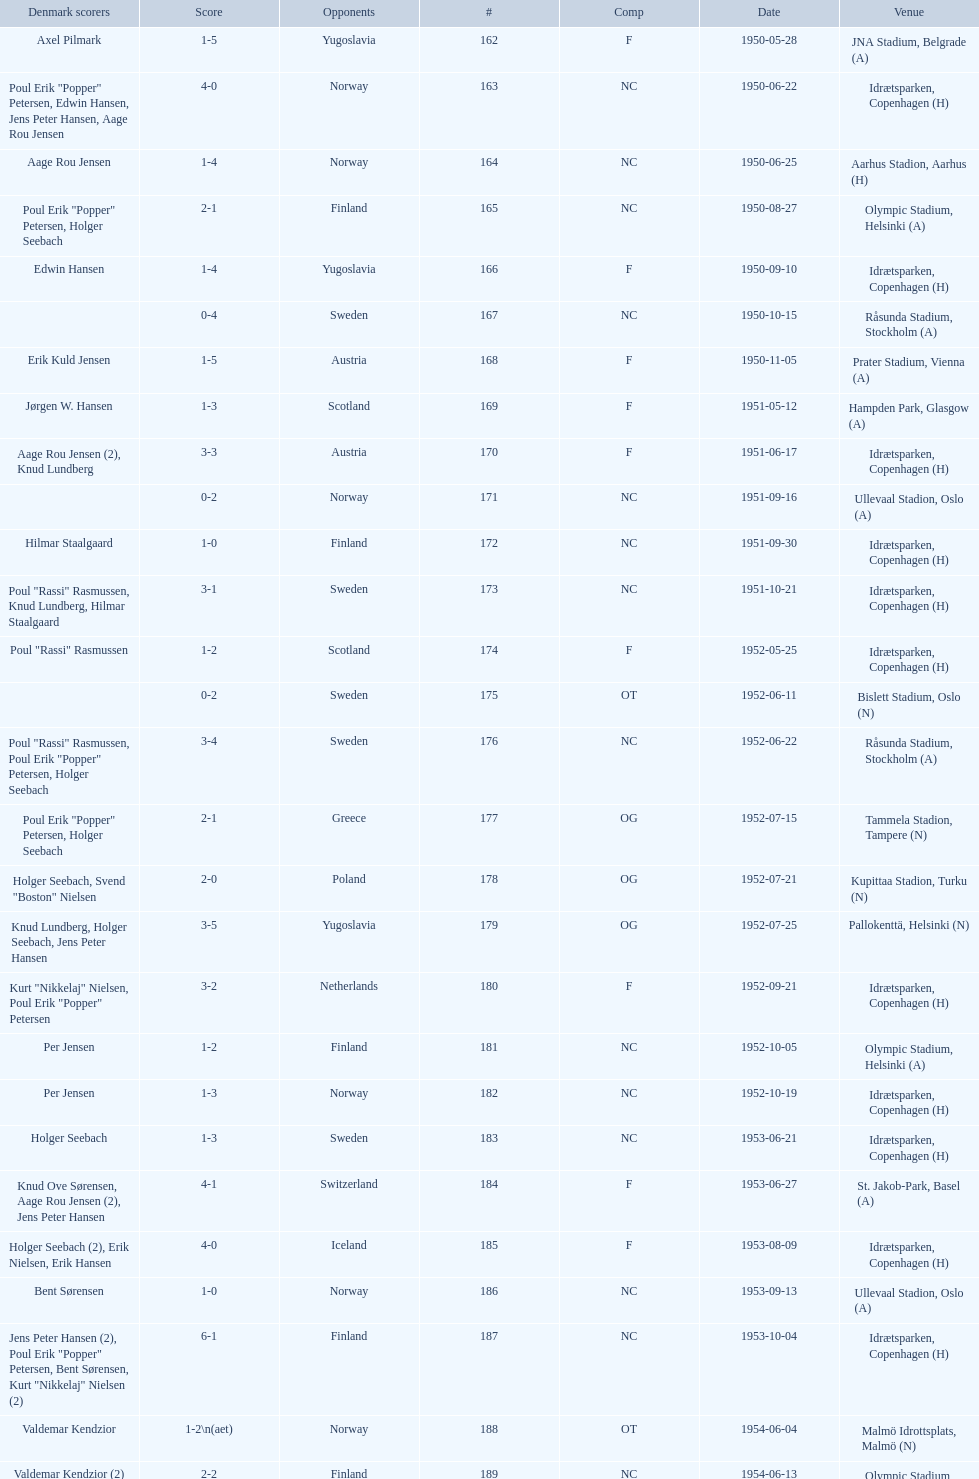Help me parse the entirety of this table. {'header': ['Denmark scorers', 'Score', 'Opponents', '#', 'Comp', 'Date', 'Venue'], 'rows': [['Axel Pilmark', '1-5', 'Yugoslavia', '162', 'F', '1950-05-28', 'JNA Stadium, Belgrade (A)'], ['Poul Erik "Popper" Petersen, Edwin Hansen, Jens Peter Hansen, Aage Rou Jensen', '4-0', 'Norway', '163', 'NC', '1950-06-22', 'Idrætsparken, Copenhagen (H)'], ['Aage Rou Jensen', '1-4', 'Norway', '164', 'NC', '1950-06-25', 'Aarhus Stadion, Aarhus (H)'], ['Poul Erik "Popper" Petersen, Holger Seebach', '2-1', 'Finland', '165', 'NC', '1950-08-27', 'Olympic Stadium, Helsinki (A)'], ['Edwin Hansen', '1-4', 'Yugoslavia', '166', 'F', '1950-09-10', 'Idrætsparken, Copenhagen (H)'], ['', '0-4', 'Sweden', '167', 'NC', '1950-10-15', 'Råsunda Stadium, Stockholm (A)'], ['Erik Kuld Jensen', '1-5', 'Austria', '168', 'F', '1950-11-05', 'Prater Stadium, Vienna (A)'], ['Jørgen W. Hansen', '1-3', 'Scotland', '169', 'F', '1951-05-12', 'Hampden Park, Glasgow (A)'], ['Aage Rou Jensen (2), Knud Lundberg', '3-3', 'Austria', '170', 'F', '1951-06-17', 'Idrætsparken, Copenhagen (H)'], ['', '0-2', 'Norway', '171', 'NC', '1951-09-16', 'Ullevaal Stadion, Oslo (A)'], ['Hilmar Staalgaard', '1-0', 'Finland', '172', 'NC', '1951-09-30', 'Idrætsparken, Copenhagen (H)'], ['Poul "Rassi" Rasmussen, Knud Lundberg, Hilmar Staalgaard', '3-1', 'Sweden', '173', 'NC', '1951-10-21', 'Idrætsparken, Copenhagen (H)'], ['Poul "Rassi" Rasmussen', '1-2', 'Scotland', '174', 'F', '1952-05-25', 'Idrætsparken, Copenhagen (H)'], ['', '0-2', 'Sweden', '175', 'OT', '1952-06-11', 'Bislett Stadium, Oslo (N)'], ['Poul "Rassi" Rasmussen, Poul Erik "Popper" Petersen, Holger Seebach', '3-4', 'Sweden', '176', 'NC', '1952-06-22', 'Råsunda Stadium, Stockholm (A)'], ['Poul Erik "Popper" Petersen, Holger Seebach', '2-1', 'Greece', '177', 'OG', '1952-07-15', 'Tammela Stadion, Tampere (N)'], ['Holger Seebach, Svend "Boston" Nielsen', '2-0', 'Poland', '178', 'OG', '1952-07-21', 'Kupittaa Stadion, Turku (N)'], ['Knud Lundberg, Holger Seebach, Jens Peter Hansen', '3-5', 'Yugoslavia', '179', 'OG', '1952-07-25', 'Pallokenttä, Helsinki (N)'], ['Kurt "Nikkelaj" Nielsen, Poul Erik "Popper" Petersen', '3-2', 'Netherlands', '180', 'F', '1952-09-21', 'Idrætsparken, Copenhagen (H)'], ['Per Jensen', '1-2', 'Finland', '181', 'NC', '1952-10-05', 'Olympic Stadium, Helsinki (A)'], ['Per Jensen', '1-3', 'Norway', '182', 'NC', '1952-10-19', 'Idrætsparken, Copenhagen (H)'], ['Holger Seebach', '1-3', 'Sweden', '183', 'NC', '1953-06-21', 'Idrætsparken, Copenhagen (H)'], ['Knud Ove Sørensen, Aage Rou Jensen (2), Jens Peter Hansen', '4-1', 'Switzerland', '184', 'F', '1953-06-27', 'St. Jakob-Park, Basel (A)'], ['Holger Seebach (2), Erik Nielsen, Erik Hansen', '4-0', 'Iceland', '185', 'F', '1953-08-09', 'Idrætsparken, Copenhagen (H)'], ['Bent Sørensen', '1-0', 'Norway', '186', 'NC', '1953-09-13', 'Ullevaal Stadion, Oslo (A)'], ['Jens Peter Hansen (2), Poul Erik "Popper" Petersen, Bent Sørensen, Kurt "Nikkelaj" Nielsen (2)', '6-1', 'Finland', '187', 'NC', '1953-10-04', 'Idrætsparken, Copenhagen (H)'], ['Valdemar Kendzior', '1-2\\n(aet)', 'Norway', '188', 'OT', '1954-06-04', 'Malmö Idrottsplats, Malmö (N)'], ['Valdemar Kendzior (2)', '2-2', 'Finland', '189', 'NC', '1954-06-13', 'Olympic Stadium, Helsinki (A)'], ['Jørgen Olesen', '1-1', 'Switzerland', '190', 'F', '1954-09-19', 'Idrætsparken, Copenhagen (H)'], ['Jens Peter Hansen, Bent Sørensen', '2-5', 'Sweden', '191', 'NC', '1954-10-10', 'Råsunda Stadium, Stockholm (A)'], ['', '0-1', 'Norway', '192', 'NC', '1954-10-31', 'Idrætsparken, Copenhagen (H)'], ['Vagn Birkeland', '1-1', 'Netherlands', '193', 'F', '1955-03-13', 'Olympic Stadium, Amsterdam (A)'], ['', '0-6', 'Hungary', '194', 'F', '1955-05-15', 'Idrætsparken, Copenhagen (H)'], ['Jens Peter Hansen (2)', '2-1', 'Finland', '195', 'NC', '1955-06-19', 'Idrætsparken, Copenhagen (H)'], ['Aage Rou Jensen, Jens Peter Hansen, Poul Pedersen (2)', '4-0', 'Iceland', '196', 'F', '1955-06-03', 'Melavollur, Reykjavík (A)'], ['Jørgen Jacobsen', '1-1', 'Norway', '197', 'NC', '1955-09-11', 'Ullevaal Stadion, Oslo (A)'], ['Knud Lundberg', '1-5', 'England', '198', 'NC', '1955-10-02', 'Idrætsparken, Copenhagen (H)'], ['Ove Andersen (2), Knud Lundberg', '3-3', 'Sweden', '199', 'NC', '1955-10-16', 'Idrætsparken, Copenhagen (H)'], ['Knud Lundberg', '1-5', 'USSR', '200', 'F', '1956-05-23', 'Dynamo Stadium, Moscow (A)'], ['Knud Lundberg, Poul Pedersen', '2-3', 'Norway', '201', 'NC', '1956-06-24', 'Idrætsparken, Copenhagen (H)'], ['Ove Andersen, Aage Rou Jensen', '2-5', 'USSR', '202', 'F', '1956-07-01', 'Idrætsparken, Copenhagen (H)'], ['Poul Pedersen, Jørgen Hansen, Ove Andersen (2)', '4-0', 'Finland', '203', 'NC', '1956-09-16', 'Olympic Stadium, Helsinki (A)'], ['Aage Rou Jensen', '1-2', 'Republic of Ireland', '204', 'WCQ', '1956-10-03', 'Dalymount Park, Dublin (A)'], ['Jens Peter Hansen', '1-1', 'Sweden', '205', 'NC', '1956-10-21', 'Råsunda Stadium, Stockholm (A)'], ['Jørgen Olesen, Knud Lundberg', '2-2', 'Netherlands', '206', 'F', '1956-11-04', 'Idrætsparken, Copenhagen (H)'], ['Ove Bech Nielsen (2)', '2-5', 'England', '207', 'WCQ', '1956-12-05', 'Molineux, Wolverhampton (A)'], ['John Jensen', '1-4', 'England', '208', 'WCQ', '1957-05-15', 'Idrætsparken, Copenhagen (H)'], ['Aage Rou Jensen', '1-1', 'Bulgaria', '209', 'F', '1957-05-26', 'Idrætsparken, Copenhagen (H)'], ['', '0-2', 'Finland', '210', 'OT', '1957-06-18', 'Olympic Stadium, Helsinki (A)'], ['Egon Jensen, Jørgen Hansen', '2-0', 'Norway', '211', 'OT', '1957-06-19', 'Tammela Stadion, Tampere (N)'], ['Jens Peter Hansen', '1-2', 'Sweden', '212', 'NC', '1957-06-30', 'Idrætsparken, Copenhagen (H)'], ['Egon Jensen (3), Poul Pedersen, Jens Peter Hansen (2)', '6-2', 'Iceland', '213', 'OT', '1957-07-10', 'Laugardalsvöllur, Reykjavík (A)'], ['Poul Pedersen, Peder Kjær', '2-2', 'Norway', '214', 'NC', '1957-09-22', 'Ullevaal Stadion, Oslo (A)'], ['', '0-2', 'Republic of Ireland', '215', 'WCQ', '1957-10-02', 'Idrætsparken, Copenhagen (H)'], ['Finn Alfred Hansen, Ove Bech Nielsen, Mogens Machon', '3-0', 'Finland', '216', 'NC', '1957-10-13', 'Idrætsparken, Copenhagen (H)'], ['Poul Pedersen, Henning Enoksen (2)', '3-2', 'Curaçao', '217', 'F', '1958-05-15', 'Aarhus Stadion, Aarhus (H)'], ['Jørn Sørensen, Poul Pedersen (2)', '3-2', 'Poland', '218', 'F', '1958-05-25', 'Idrætsparken, Copenhagen (H)'], ['Poul Pedersen', '1-2', 'Norway', '219', 'NC', '1958-06-29', 'Idrætsparken, Copenhagen (H)'], ['Poul Pedersen, Mogens Machon, John Danielsen (2)', '4-1', 'Finland', '220', 'NC', '1958-09-14', 'Olympic Stadium, Helsinki (A)'], ['Henning Enoksen', '1-1', 'West Germany', '221', 'F', '1958-09-24', 'Idrætsparken, Copenhagen (H)'], ['Henning Enoksen', '1-5', 'Netherlands', '222', 'F', '1958-10-15', 'Idrætsparken, Copenhagen (H)'], ['Ole Madsen (2), Henning Enoksen, Jørn Sørensen', '4-4', 'Sweden', '223', 'NC', '1958-10-26', 'Råsunda Stadium, Stockholm (A)'], ['', '0-6', 'Sweden', '224', 'NC', '1959-06-21', 'Idrætsparken, Copenhagen (H)'], ['Jens Peter Hansen (2), Ole Madsen (2)', '4-2', 'Iceland', '225', 'OGQ', '1959-06-26', 'Laugardalsvöllur, Reykjavík (A)'], ['Henning Enoksen, Ole Madsen', '2-1', 'Norway', '226', 'OGQ', '1959-07-02', 'Idrætsparken, Copenhagen (H)'], ['Henning Enoksen', '1-1', 'Iceland', '227', 'OGQ', '1959-08-18', 'Idrætsparken, Copenhagen (H)'], ['Harald Nielsen, Henning Enoksen (2), Poul Pedersen', '4-2', 'Norway', '228', 'OGQ\\nNC', '1959-09-13', 'Ullevaal Stadion, Oslo (A)'], ['Poul Pedersen, Bent Hansen', '2-2', 'Czechoslovakia', '229', 'ENQ', '1959-09-23', 'Idrætsparken, Copenhagen (H)'], ['Harald Nielsen (3), John Kramer', '4-0', 'Finland', '230', 'NC', '1959-10-04', 'Idrætsparken, Copenhagen (H)'], ['John Kramer', '1-5', 'Czechoslovakia', '231', 'ENQ', '1959-10-18', 'Stadion Za Lužánkami, Brno (A)'], ['Henning Enoksen (2), Poul Pedersen', '3-1', 'Greece', '232', 'F', '1959-12-02', 'Olympic Stadium, Athens (A)'], ['Henning Enoksen', '1-2', 'Bulgaria', '233', 'F', '1959-12-06', 'Vasil Levski National Stadium, Sofia (A)']]} In the game that took place immediately prior to july 25, 1952, who were they up against? Poland. 